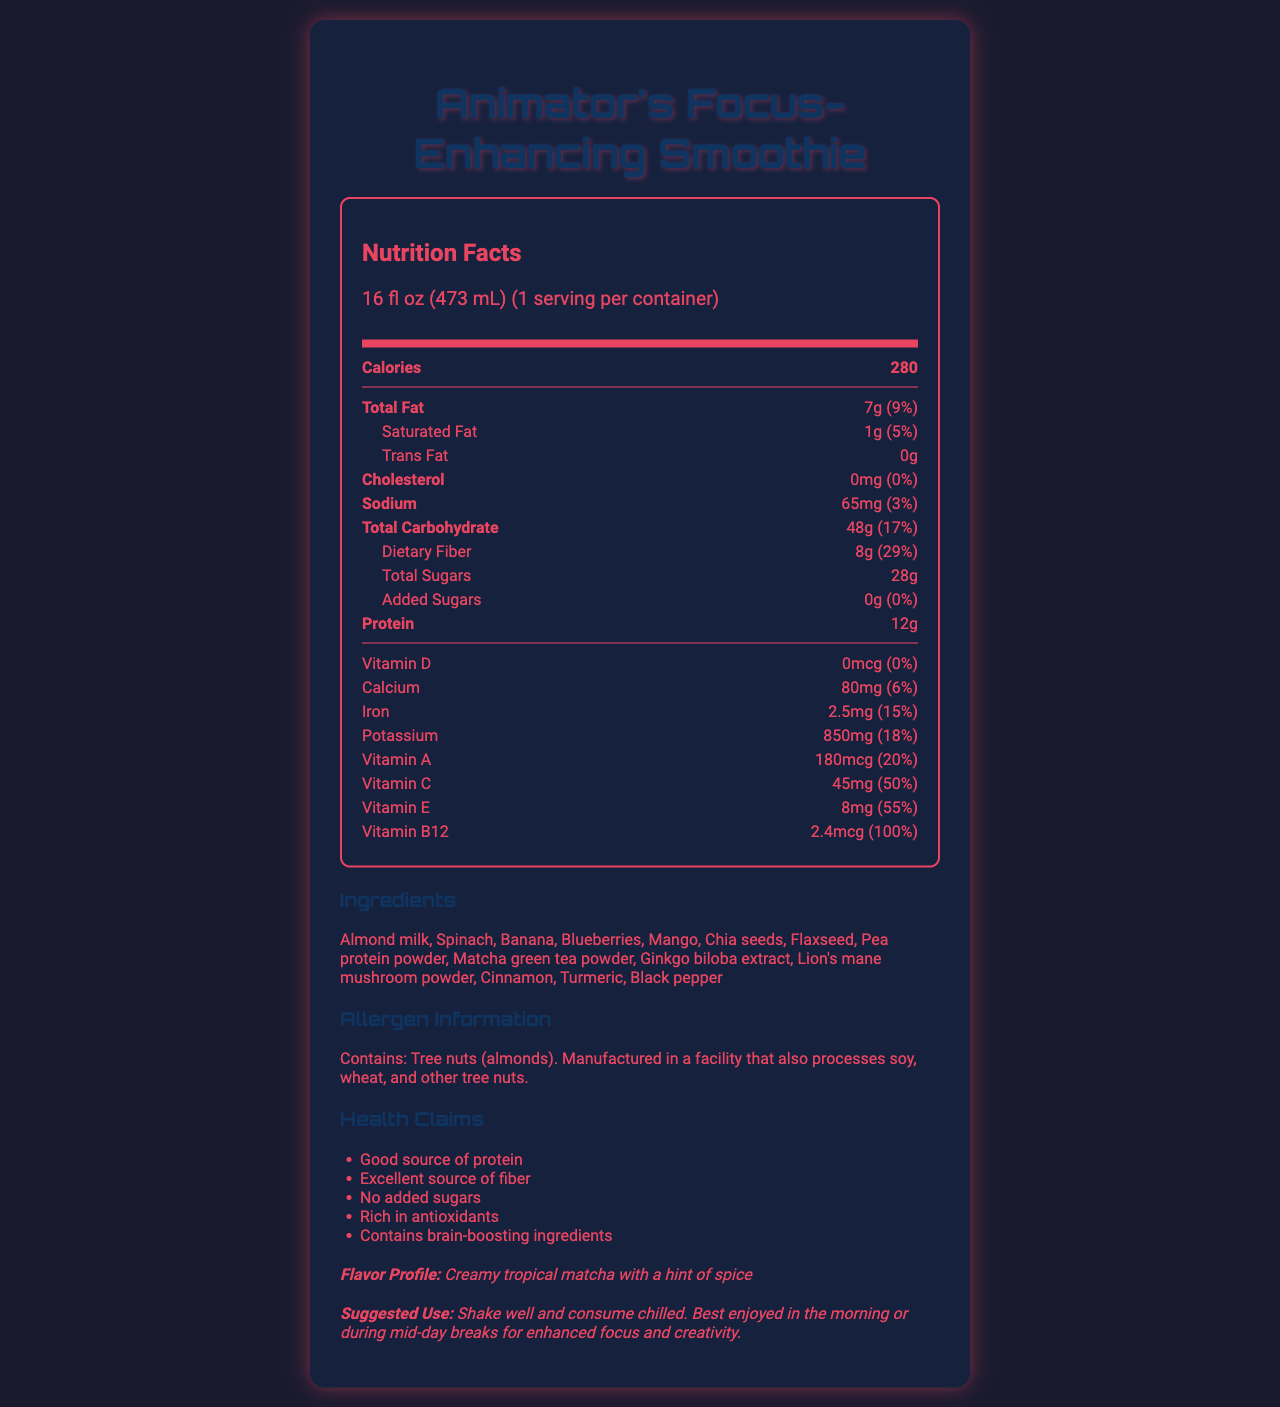what is the total fat content in the smoothie? The total fat content is specified in the document as 7g.
Answer: 7g how many calories are in one serving of the smoothie? The document states that one serving of the smoothie contains 280 calories.
Answer: 280 what is the protein content and its daily value percentage? The protein content is listed as 12g, which represents 24% of the daily value.
Answer: 12g, 24% what are the main ingredients listed in the smoothie? These are all the ingredients listed under the ingredients section of the document.
Answer: Almond milk, Spinach, Banana, Blueberries, Mango, Chia seeds, Flaxseed, Pea protein powder, Matcha green tea powder, Ginkgo biloba extract, Lion's mane mushroom powder, Cinnamon, Turmeric, Black pepper how much dietary fiber does the smoothie contain? The smoothie contains 8g of dietary fiber, as specified in the document.
Answer: 8g what is the flavor profile of the smoothie? A. Fruity and Spicy B. Creamy tropical matcha with a hint of spice C. Chocolate and Mint D. Nutty and Savory The document describes the flavor profile as "Creamy tropical matcha with a hint of spice."
Answer: B which vitamin provides the highest daily value percentage? I. Vitamin D (0%) II. Vitamin B12 (100%) III. Vitamin C (50%) IV. Vitamin E (55%) Vitamin B12 provides the highest daily value percentage at 100%.
Answer: II does this product contain any added sugars? According to the document, the smoothie contains 0g of added sugars.
Answer: No is this product a good source of protein? One of the health claims listed in the document is that it is a "Good source of protein."
Answer: Yes describe the main idea of the document. The document details comprehensive dietary information about the animator's focus-enhancing smoothie, highlighting its nutritional content, key ingredients, allergens, health benefits, and intended use.
Answer: The document provides the nutrition facts, ingredients, allergen information, health claims, flavor profile, and suggested use for "Animator's Focus-Enhancing Smoothie." The smoothie is designed to enhance focus and creativity, with specific nutritional content including high amounts of protein, dietary fiber, and various vitamins. It also contains brain-boosting ingredients. how much vitamin D is in the smoothie? The document states that there is 0 mcg of vitamin D in the smoothie.
Answer: 0 mcg where is this product manufactured? The document mentions that the product is manufactured in a facility that processes certain allergens but does not specify the location of the manufacturing facility.
Answer: Cannot be determined what kind of nuts does the smoothie contain? The allergen information specifies that the product contains tree nuts, specifically almonds.
Answer: Tree nuts (almonds) which of the following is not an ingredient in the smoothie? A. Spinach B. Banana C. Chocolate D. Blueberries Chocolate is not listed as one of the ingredients in the smoothie.
Answer: C are there any health claims about the smoothie being rich in antioxidants? One of the health claims in the document mentions that the smoothie is "Rich in antioxidants."
Answer: Yes 